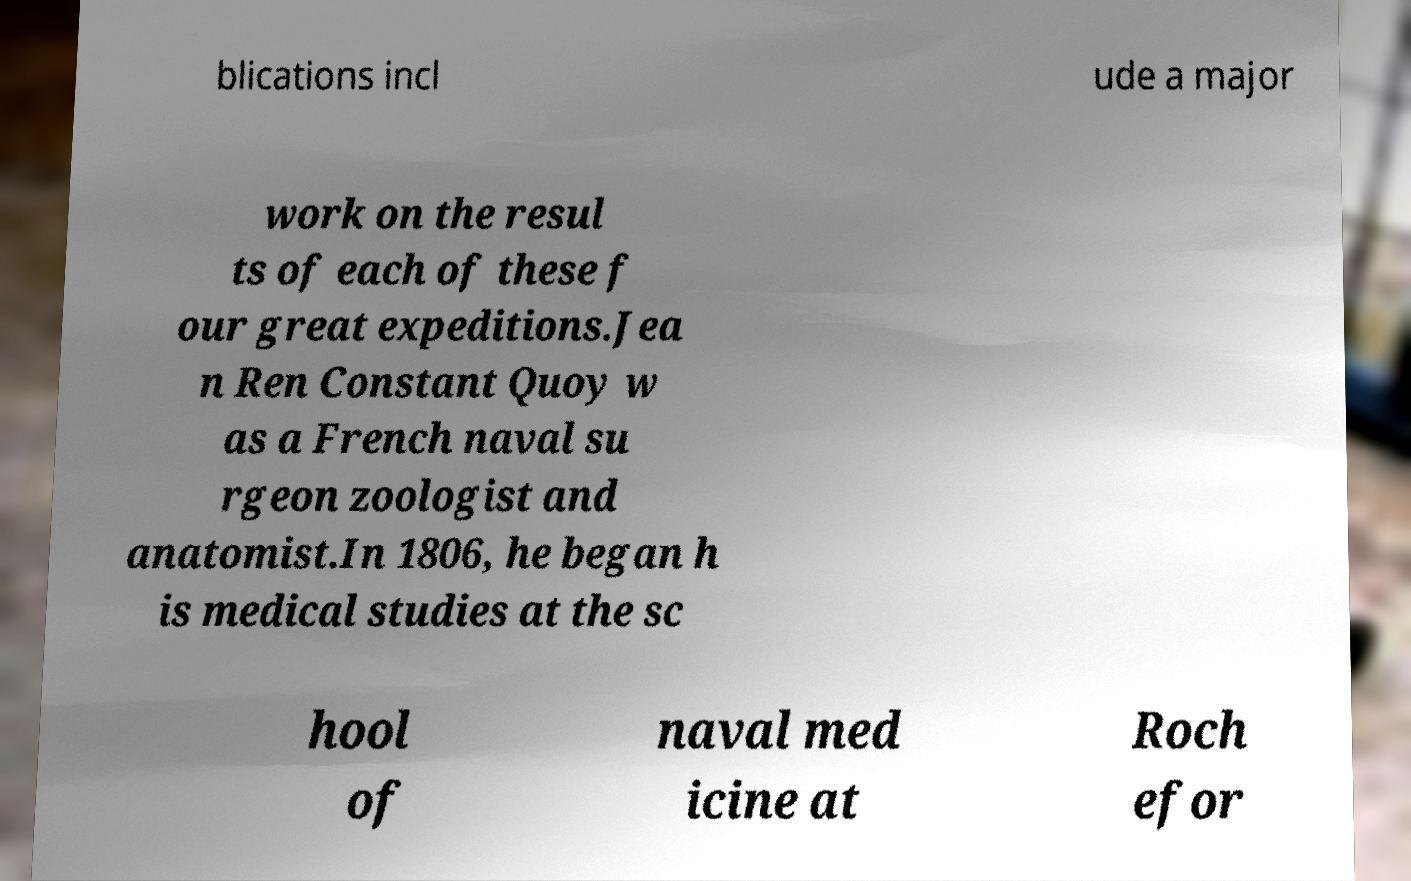For documentation purposes, I need the text within this image transcribed. Could you provide that? blications incl ude a major work on the resul ts of each of these f our great expeditions.Jea n Ren Constant Quoy w as a French naval su rgeon zoologist and anatomist.In 1806, he began h is medical studies at the sc hool of naval med icine at Roch efor 